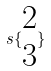Convert formula to latex. <formula><loc_0><loc_0><loc_500><loc_500>s \{ \begin{matrix} 2 \\ 3 \end{matrix} \}</formula> 